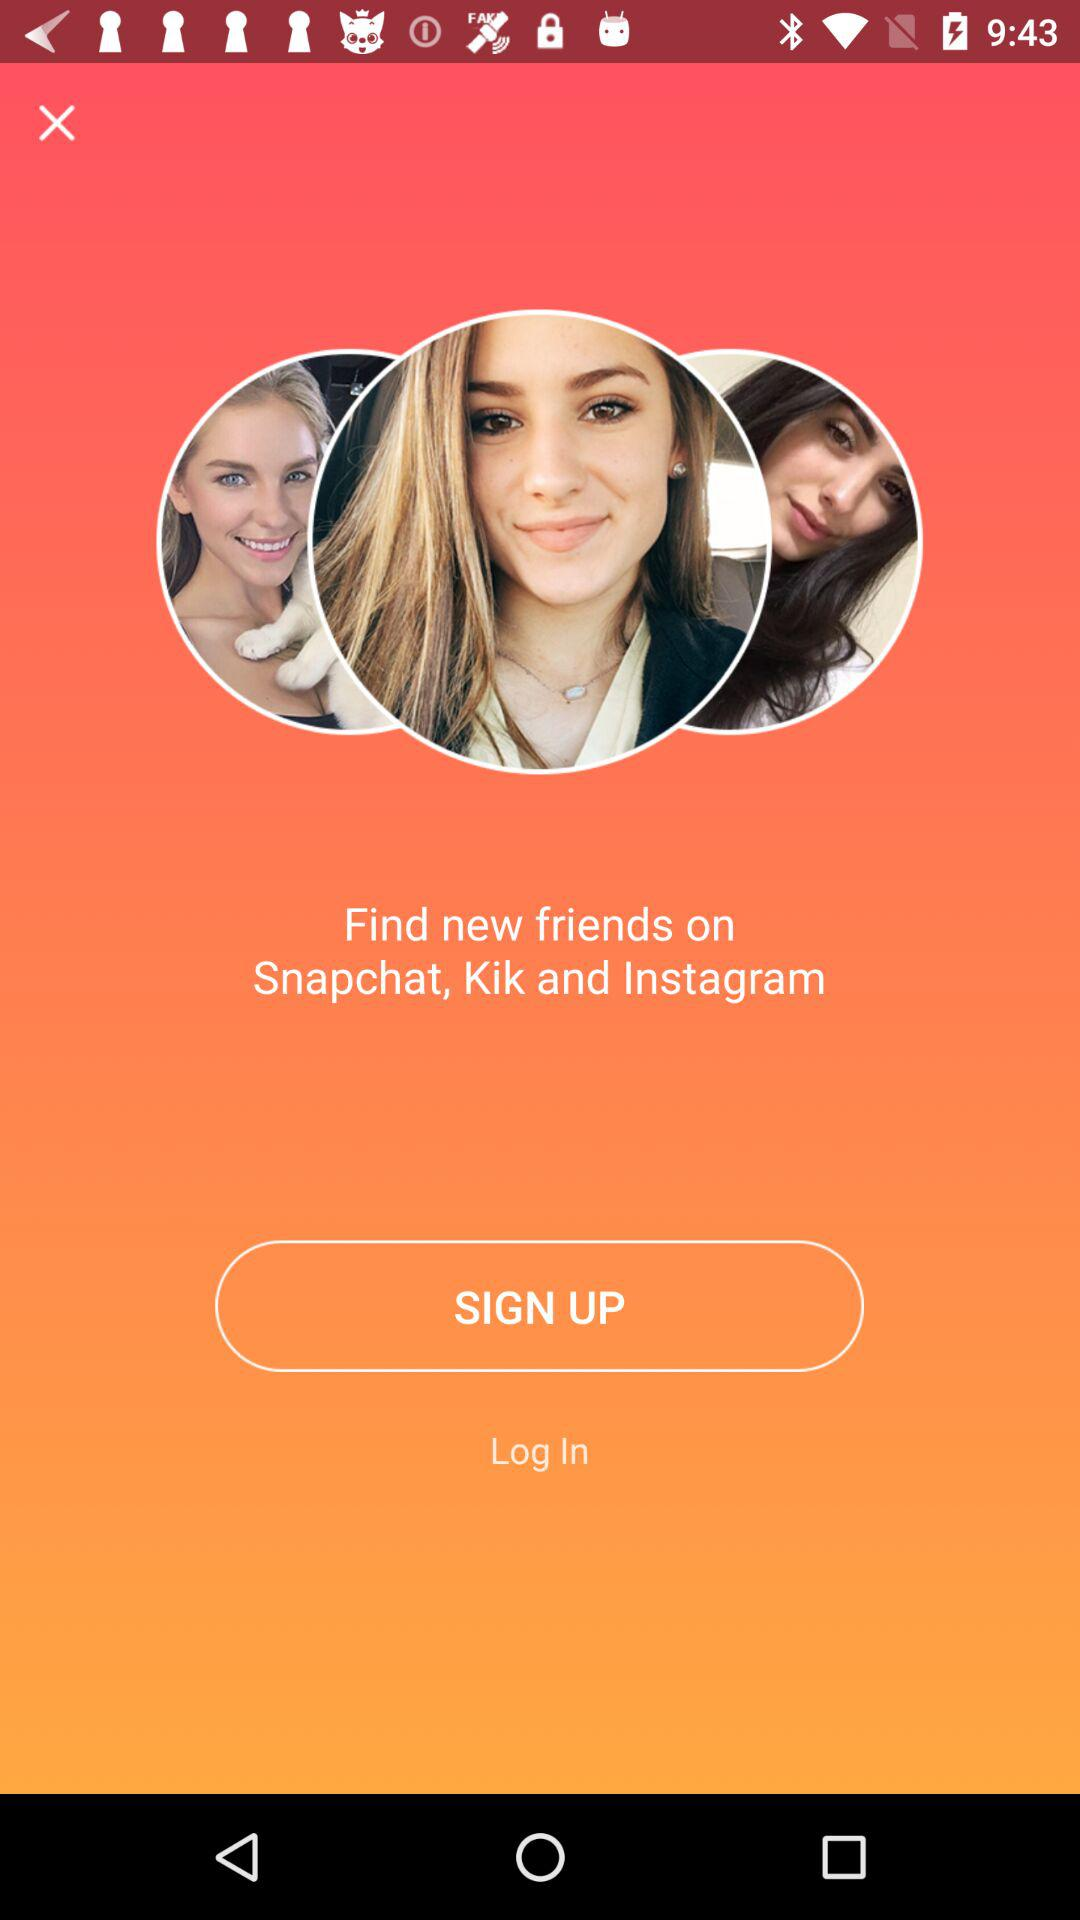Where can we find new friends? You can find new friends on "Snapchat", "Kik" and "Instagram". 